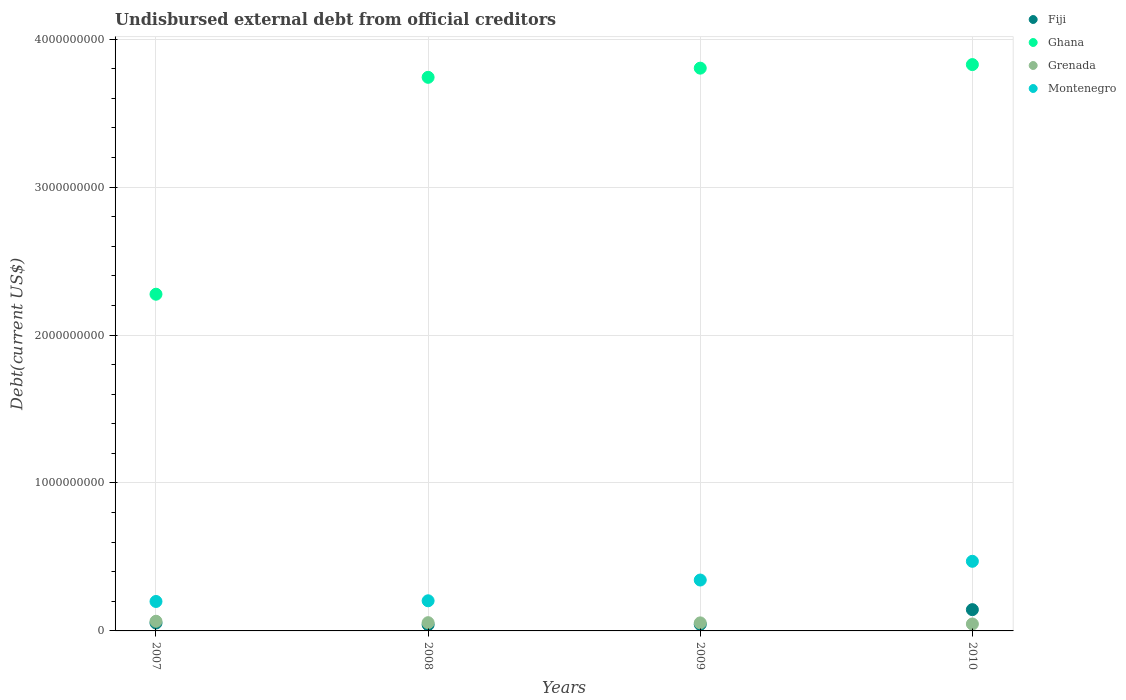How many different coloured dotlines are there?
Provide a short and direct response. 4. What is the total debt in Montenegro in 2009?
Your response must be concise. 3.44e+08. Across all years, what is the maximum total debt in Montenegro?
Your answer should be very brief. 4.71e+08. Across all years, what is the minimum total debt in Fiji?
Your answer should be very brief. 4.18e+07. What is the total total debt in Ghana in the graph?
Offer a very short reply. 1.37e+1. What is the difference between the total debt in Montenegro in 2007 and that in 2008?
Your answer should be compact. -4.64e+06. What is the difference between the total debt in Montenegro in 2009 and the total debt in Ghana in 2010?
Your answer should be very brief. -3.48e+09. What is the average total debt in Grenada per year?
Provide a short and direct response. 5.56e+07. In the year 2009, what is the difference between the total debt in Fiji and total debt in Grenada?
Your answer should be compact. -1.00e+07. In how many years, is the total debt in Montenegro greater than 1200000000 US$?
Make the answer very short. 0. What is the ratio of the total debt in Montenegro in 2009 to that in 2010?
Give a very brief answer. 0.73. Is the total debt in Fiji in 2007 less than that in 2008?
Provide a short and direct response. No. What is the difference between the highest and the second highest total debt in Grenada?
Your answer should be very brief. 9.50e+06. What is the difference between the highest and the lowest total debt in Fiji?
Give a very brief answer. 1.02e+08. In how many years, is the total debt in Montenegro greater than the average total debt in Montenegro taken over all years?
Give a very brief answer. 2. Is it the case that in every year, the sum of the total debt in Ghana and total debt in Montenegro  is greater than the sum of total debt in Fiji and total debt in Grenada?
Give a very brief answer. Yes. Does the total debt in Grenada monotonically increase over the years?
Offer a very short reply. No. Is the total debt in Ghana strictly greater than the total debt in Fiji over the years?
Your answer should be very brief. Yes. How many years are there in the graph?
Offer a terse response. 4. What is the difference between two consecutive major ticks on the Y-axis?
Ensure brevity in your answer.  1.00e+09. Where does the legend appear in the graph?
Provide a short and direct response. Top right. What is the title of the graph?
Offer a very short reply. Undisbursed external debt from official creditors. What is the label or title of the X-axis?
Your response must be concise. Years. What is the label or title of the Y-axis?
Provide a succinct answer. Debt(current US$). What is the Debt(current US$) of Fiji in 2007?
Give a very brief answer. 5.36e+07. What is the Debt(current US$) of Ghana in 2007?
Make the answer very short. 2.28e+09. What is the Debt(current US$) in Grenada in 2007?
Your answer should be very brief. 6.52e+07. What is the Debt(current US$) in Montenegro in 2007?
Provide a succinct answer. 1.99e+08. What is the Debt(current US$) of Fiji in 2008?
Your answer should be very brief. 4.18e+07. What is the Debt(current US$) of Ghana in 2008?
Provide a succinct answer. 3.74e+09. What is the Debt(current US$) in Grenada in 2008?
Your answer should be compact. 5.57e+07. What is the Debt(current US$) of Montenegro in 2008?
Ensure brevity in your answer.  2.04e+08. What is the Debt(current US$) of Fiji in 2009?
Provide a short and direct response. 4.44e+07. What is the Debt(current US$) of Ghana in 2009?
Provide a short and direct response. 3.80e+09. What is the Debt(current US$) of Grenada in 2009?
Offer a very short reply. 5.44e+07. What is the Debt(current US$) of Montenegro in 2009?
Ensure brevity in your answer.  3.44e+08. What is the Debt(current US$) in Fiji in 2010?
Your answer should be compact. 1.44e+08. What is the Debt(current US$) of Ghana in 2010?
Your answer should be compact. 3.83e+09. What is the Debt(current US$) in Grenada in 2010?
Your answer should be compact. 4.69e+07. What is the Debt(current US$) of Montenegro in 2010?
Give a very brief answer. 4.71e+08. Across all years, what is the maximum Debt(current US$) of Fiji?
Make the answer very short. 1.44e+08. Across all years, what is the maximum Debt(current US$) of Ghana?
Make the answer very short. 3.83e+09. Across all years, what is the maximum Debt(current US$) in Grenada?
Provide a succinct answer. 6.52e+07. Across all years, what is the maximum Debt(current US$) in Montenegro?
Offer a terse response. 4.71e+08. Across all years, what is the minimum Debt(current US$) in Fiji?
Keep it short and to the point. 4.18e+07. Across all years, what is the minimum Debt(current US$) in Ghana?
Give a very brief answer. 2.28e+09. Across all years, what is the minimum Debt(current US$) in Grenada?
Your answer should be very brief. 4.69e+07. Across all years, what is the minimum Debt(current US$) in Montenegro?
Provide a short and direct response. 1.99e+08. What is the total Debt(current US$) of Fiji in the graph?
Your answer should be compact. 2.84e+08. What is the total Debt(current US$) of Ghana in the graph?
Offer a very short reply. 1.37e+1. What is the total Debt(current US$) in Grenada in the graph?
Provide a succinct answer. 2.22e+08. What is the total Debt(current US$) in Montenegro in the graph?
Offer a terse response. 1.22e+09. What is the difference between the Debt(current US$) of Fiji in 2007 and that in 2008?
Keep it short and to the point. 1.18e+07. What is the difference between the Debt(current US$) in Ghana in 2007 and that in 2008?
Make the answer very short. -1.47e+09. What is the difference between the Debt(current US$) of Grenada in 2007 and that in 2008?
Your answer should be compact. 9.50e+06. What is the difference between the Debt(current US$) in Montenegro in 2007 and that in 2008?
Give a very brief answer. -4.64e+06. What is the difference between the Debt(current US$) in Fiji in 2007 and that in 2009?
Provide a succinct answer. 9.20e+06. What is the difference between the Debt(current US$) in Ghana in 2007 and that in 2009?
Provide a succinct answer. -1.53e+09. What is the difference between the Debt(current US$) in Grenada in 2007 and that in 2009?
Provide a succinct answer. 1.08e+07. What is the difference between the Debt(current US$) of Montenegro in 2007 and that in 2009?
Keep it short and to the point. -1.45e+08. What is the difference between the Debt(current US$) of Fiji in 2007 and that in 2010?
Provide a succinct answer. -9.02e+07. What is the difference between the Debt(current US$) of Ghana in 2007 and that in 2010?
Keep it short and to the point. -1.55e+09. What is the difference between the Debt(current US$) of Grenada in 2007 and that in 2010?
Your answer should be very brief. 1.83e+07. What is the difference between the Debt(current US$) of Montenegro in 2007 and that in 2010?
Provide a succinct answer. -2.72e+08. What is the difference between the Debt(current US$) in Fiji in 2008 and that in 2009?
Keep it short and to the point. -2.61e+06. What is the difference between the Debt(current US$) in Ghana in 2008 and that in 2009?
Your response must be concise. -6.20e+07. What is the difference between the Debt(current US$) of Grenada in 2008 and that in 2009?
Give a very brief answer. 1.34e+06. What is the difference between the Debt(current US$) of Montenegro in 2008 and that in 2009?
Provide a short and direct response. -1.40e+08. What is the difference between the Debt(current US$) in Fiji in 2008 and that in 2010?
Provide a succinct answer. -1.02e+08. What is the difference between the Debt(current US$) in Ghana in 2008 and that in 2010?
Keep it short and to the point. -8.61e+07. What is the difference between the Debt(current US$) of Grenada in 2008 and that in 2010?
Give a very brief answer. 8.79e+06. What is the difference between the Debt(current US$) in Montenegro in 2008 and that in 2010?
Provide a short and direct response. -2.67e+08. What is the difference between the Debt(current US$) in Fiji in 2009 and that in 2010?
Give a very brief answer. -9.94e+07. What is the difference between the Debt(current US$) of Ghana in 2009 and that in 2010?
Make the answer very short. -2.42e+07. What is the difference between the Debt(current US$) of Grenada in 2009 and that in 2010?
Ensure brevity in your answer.  7.44e+06. What is the difference between the Debt(current US$) in Montenegro in 2009 and that in 2010?
Offer a very short reply. -1.27e+08. What is the difference between the Debt(current US$) in Fiji in 2007 and the Debt(current US$) in Ghana in 2008?
Offer a terse response. -3.69e+09. What is the difference between the Debt(current US$) of Fiji in 2007 and the Debt(current US$) of Grenada in 2008?
Offer a terse response. -2.15e+06. What is the difference between the Debt(current US$) in Fiji in 2007 and the Debt(current US$) in Montenegro in 2008?
Make the answer very short. -1.50e+08. What is the difference between the Debt(current US$) of Ghana in 2007 and the Debt(current US$) of Grenada in 2008?
Provide a short and direct response. 2.22e+09. What is the difference between the Debt(current US$) in Ghana in 2007 and the Debt(current US$) in Montenegro in 2008?
Offer a terse response. 2.07e+09. What is the difference between the Debt(current US$) of Grenada in 2007 and the Debt(current US$) of Montenegro in 2008?
Make the answer very short. -1.38e+08. What is the difference between the Debt(current US$) of Fiji in 2007 and the Debt(current US$) of Ghana in 2009?
Your answer should be compact. -3.75e+09. What is the difference between the Debt(current US$) in Fiji in 2007 and the Debt(current US$) in Grenada in 2009?
Give a very brief answer. -8.05e+05. What is the difference between the Debt(current US$) of Fiji in 2007 and the Debt(current US$) of Montenegro in 2009?
Keep it short and to the point. -2.90e+08. What is the difference between the Debt(current US$) in Ghana in 2007 and the Debt(current US$) in Grenada in 2009?
Make the answer very short. 2.22e+09. What is the difference between the Debt(current US$) in Ghana in 2007 and the Debt(current US$) in Montenegro in 2009?
Your response must be concise. 1.93e+09. What is the difference between the Debt(current US$) in Grenada in 2007 and the Debt(current US$) in Montenegro in 2009?
Provide a succinct answer. -2.79e+08. What is the difference between the Debt(current US$) of Fiji in 2007 and the Debt(current US$) of Ghana in 2010?
Your answer should be compact. -3.77e+09. What is the difference between the Debt(current US$) in Fiji in 2007 and the Debt(current US$) in Grenada in 2010?
Ensure brevity in your answer.  6.64e+06. What is the difference between the Debt(current US$) in Fiji in 2007 and the Debt(current US$) in Montenegro in 2010?
Provide a short and direct response. -4.17e+08. What is the difference between the Debt(current US$) in Ghana in 2007 and the Debt(current US$) in Grenada in 2010?
Your response must be concise. 2.23e+09. What is the difference between the Debt(current US$) of Ghana in 2007 and the Debt(current US$) of Montenegro in 2010?
Offer a very short reply. 1.81e+09. What is the difference between the Debt(current US$) in Grenada in 2007 and the Debt(current US$) in Montenegro in 2010?
Your answer should be compact. -4.05e+08. What is the difference between the Debt(current US$) in Fiji in 2008 and the Debt(current US$) in Ghana in 2009?
Your response must be concise. -3.76e+09. What is the difference between the Debt(current US$) in Fiji in 2008 and the Debt(current US$) in Grenada in 2009?
Make the answer very short. -1.26e+07. What is the difference between the Debt(current US$) of Fiji in 2008 and the Debt(current US$) of Montenegro in 2009?
Provide a short and direct response. -3.02e+08. What is the difference between the Debt(current US$) of Ghana in 2008 and the Debt(current US$) of Grenada in 2009?
Give a very brief answer. 3.69e+09. What is the difference between the Debt(current US$) in Ghana in 2008 and the Debt(current US$) in Montenegro in 2009?
Provide a succinct answer. 3.40e+09. What is the difference between the Debt(current US$) in Grenada in 2008 and the Debt(current US$) in Montenegro in 2009?
Give a very brief answer. -2.88e+08. What is the difference between the Debt(current US$) of Fiji in 2008 and the Debt(current US$) of Ghana in 2010?
Make the answer very short. -3.79e+09. What is the difference between the Debt(current US$) in Fiji in 2008 and the Debt(current US$) in Grenada in 2010?
Give a very brief answer. -5.16e+06. What is the difference between the Debt(current US$) in Fiji in 2008 and the Debt(current US$) in Montenegro in 2010?
Keep it short and to the point. -4.29e+08. What is the difference between the Debt(current US$) in Ghana in 2008 and the Debt(current US$) in Grenada in 2010?
Your answer should be compact. 3.70e+09. What is the difference between the Debt(current US$) of Ghana in 2008 and the Debt(current US$) of Montenegro in 2010?
Ensure brevity in your answer.  3.27e+09. What is the difference between the Debt(current US$) in Grenada in 2008 and the Debt(current US$) in Montenegro in 2010?
Ensure brevity in your answer.  -4.15e+08. What is the difference between the Debt(current US$) in Fiji in 2009 and the Debt(current US$) in Ghana in 2010?
Give a very brief answer. -3.78e+09. What is the difference between the Debt(current US$) in Fiji in 2009 and the Debt(current US$) in Grenada in 2010?
Offer a terse response. -2.56e+06. What is the difference between the Debt(current US$) in Fiji in 2009 and the Debt(current US$) in Montenegro in 2010?
Your response must be concise. -4.26e+08. What is the difference between the Debt(current US$) of Ghana in 2009 and the Debt(current US$) of Grenada in 2010?
Provide a short and direct response. 3.76e+09. What is the difference between the Debt(current US$) of Ghana in 2009 and the Debt(current US$) of Montenegro in 2010?
Offer a very short reply. 3.33e+09. What is the difference between the Debt(current US$) of Grenada in 2009 and the Debt(current US$) of Montenegro in 2010?
Give a very brief answer. -4.16e+08. What is the average Debt(current US$) of Fiji per year?
Your answer should be compact. 7.09e+07. What is the average Debt(current US$) in Ghana per year?
Your answer should be very brief. 3.41e+09. What is the average Debt(current US$) in Grenada per year?
Your response must be concise. 5.56e+07. What is the average Debt(current US$) in Montenegro per year?
Ensure brevity in your answer.  3.04e+08. In the year 2007, what is the difference between the Debt(current US$) of Fiji and Debt(current US$) of Ghana?
Provide a short and direct response. -2.22e+09. In the year 2007, what is the difference between the Debt(current US$) of Fiji and Debt(current US$) of Grenada?
Provide a succinct answer. -1.17e+07. In the year 2007, what is the difference between the Debt(current US$) of Fiji and Debt(current US$) of Montenegro?
Provide a succinct answer. -1.46e+08. In the year 2007, what is the difference between the Debt(current US$) in Ghana and Debt(current US$) in Grenada?
Your answer should be compact. 2.21e+09. In the year 2007, what is the difference between the Debt(current US$) of Ghana and Debt(current US$) of Montenegro?
Your answer should be compact. 2.08e+09. In the year 2007, what is the difference between the Debt(current US$) of Grenada and Debt(current US$) of Montenegro?
Provide a short and direct response. -1.34e+08. In the year 2008, what is the difference between the Debt(current US$) of Fiji and Debt(current US$) of Ghana?
Provide a succinct answer. -3.70e+09. In the year 2008, what is the difference between the Debt(current US$) in Fiji and Debt(current US$) in Grenada?
Your answer should be compact. -1.40e+07. In the year 2008, what is the difference between the Debt(current US$) in Fiji and Debt(current US$) in Montenegro?
Your response must be concise. -1.62e+08. In the year 2008, what is the difference between the Debt(current US$) in Ghana and Debt(current US$) in Grenada?
Provide a succinct answer. 3.69e+09. In the year 2008, what is the difference between the Debt(current US$) of Ghana and Debt(current US$) of Montenegro?
Provide a short and direct response. 3.54e+09. In the year 2008, what is the difference between the Debt(current US$) of Grenada and Debt(current US$) of Montenegro?
Provide a succinct answer. -1.48e+08. In the year 2009, what is the difference between the Debt(current US$) of Fiji and Debt(current US$) of Ghana?
Keep it short and to the point. -3.76e+09. In the year 2009, what is the difference between the Debt(current US$) of Fiji and Debt(current US$) of Grenada?
Keep it short and to the point. -1.00e+07. In the year 2009, what is the difference between the Debt(current US$) of Fiji and Debt(current US$) of Montenegro?
Make the answer very short. -3.00e+08. In the year 2009, what is the difference between the Debt(current US$) in Ghana and Debt(current US$) in Grenada?
Make the answer very short. 3.75e+09. In the year 2009, what is the difference between the Debt(current US$) in Ghana and Debt(current US$) in Montenegro?
Make the answer very short. 3.46e+09. In the year 2009, what is the difference between the Debt(current US$) of Grenada and Debt(current US$) of Montenegro?
Your answer should be compact. -2.90e+08. In the year 2010, what is the difference between the Debt(current US$) in Fiji and Debt(current US$) in Ghana?
Provide a short and direct response. -3.68e+09. In the year 2010, what is the difference between the Debt(current US$) in Fiji and Debt(current US$) in Grenada?
Your response must be concise. 9.68e+07. In the year 2010, what is the difference between the Debt(current US$) in Fiji and Debt(current US$) in Montenegro?
Offer a terse response. -3.27e+08. In the year 2010, what is the difference between the Debt(current US$) of Ghana and Debt(current US$) of Grenada?
Your response must be concise. 3.78e+09. In the year 2010, what is the difference between the Debt(current US$) in Ghana and Debt(current US$) in Montenegro?
Your answer should be very brief. 3.36e+09. In the year 2010, what is the difference between the Debt(current US$) of Grenada and Debt(current US$) of Montenegro?
Your answer should be compact. -4.24e+08. What is the ratio of the Debt(current US$) in Fiji in 2007 to that in 2008?
Provide a short and direct response. 1.28. What is the ratio of the Debt(current US$) of Ghana in 2007 to that in 2008?
Your answer should be compact. 0.61. What is the ratio of the Debt(current US$) in Grenada in 2007 to that in 2008?
Provide a short and direct response. 1.17. What is the ratio of the Debt(current US$) in Montenegro in 2007 to that in 2008?
Your answer should be very brief. 0.98. What is the ratio of the Debt(current US$) in Fiji in 2007 to that in 2009?
Give a very brief answer. 1.21. What is the ratio of the Debt(current US$) in Ghana in 2007 to that in 2009?
Ensure brevity in your answer.  0.6. What is the ratio of the Debt(current US$) of Grenada in 2007 to that in 2009?
Provide a short and direct response. 1.2. What is the ratio of the Debt(current US$) of Montenegro in 2007 to that in 2009?
Keep it short and to the point. 0.58. What is the ratio of the Debt(current US$) in Fiji in 2007 to that in 2010?
Give a very brief answer. 0.37. What is the ratio of the Debt(current US$) in Ghana in 2007 to that in 2010?
Offer a very short reply. 0.59. What is the ratio of the Debt(current US$) in Grenada in 2007 to that in 2010?
Provide a short and direct response. 1.39. What is the ratio of the Debt(current US$) of Montenegro in 2007 to that in 2010?
Keep it short and to the point. 0.42. What is the ratio of the Debt(current US$) of Fiji in 2008 to that in 2009?
Offer a very short reply. 0.94. What is the ratio of the Debt(current US$) in Ghana in 2008 to that in 2009?
Keep it short and to the point. 0.98. What is the ratio of the Debt(current US$) in Grenada in 2008 to that in 2009?
Your answer should be very brief. 1.02. What is the ratio of the Debt(current US$) of Montenegro in 2008 to that in 2009?
Your answer should be very brief. 0.59. What is the ratio of the Debt(current US$) in Fiji in 2008 to that in 2010?
Ensure brevity in your answer.  0.29. What is the ratio of the Debt(current US$) in Ghana in 2008 to that in 2010?
Give a very brief answer. 0.98. What is the ratio of the Debt(current US$) in Grenada in 2008 to that in 2010?
Your answer should be very brief. 1.19. What is the ratio of the Debt(current US$) in Montenegro in 2008 to that in 2010?
Make the answer very short. 0.43. What is the ratio of the Debt(current US$) in Fiji in 2009 to that in 2010?
Keep it short and to the point. 0.31. What is the ratio of the Debt(current US$) of Ghana in 2009 to that in 2010?
Keep it short and to the point. 0.99. What is the ratio of the Debt(current US$) in Grenada in 2009 to that in 2010?
Give a very brief answer. 1.16. What is the ratio of the Debt(current US$) in Montenegro in 2009 to that in 2010?
Offer a very short reply. 0.73. What is the difference between the highest and the second highest Debt(current US$) in Fiji?
Your answer should be very brief. 9.02e+07. What is the difference between the highest and the second highest Debt(current US$) in Ghana?
Offer a very short reply. 2.42e+07. What is the difference between the highest and the second highest Debt(current US$) of Grenada?
Provide a succinct answer. 9.50e+06. What is the difference between the highest and the second highest Debt(current US$) in Montenegro?
Offer a very short reply. 1.27e+08. What is the difference between the highest and the lowest Debt(current US$) of Fiji?
Make the answer very short. 1.02e+08. What is the difference between the highest and the lowest Debt(current US$) of Ghana?
Your response must be concise. 1.55e+09. What is the difference between the highest and the lowest Debt(current US$) in Grenada?
Offer a terse response. 1.83e+07. What is the difference between the highest and the lowest Debt(current US$) of Montenegro?
Your answer should be compact. 2.72e+08. 